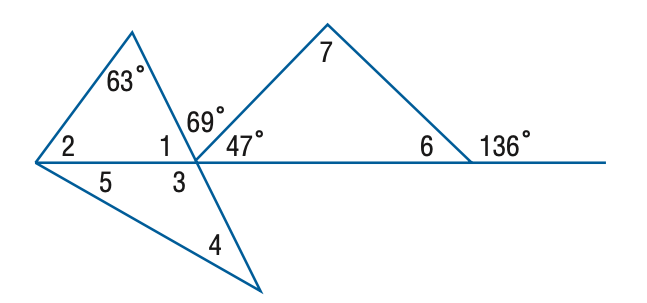Answer the mathemtical geometry problem and directly provide the correct option letter.
Question: Find the measure of \angle 4 if m \angle 4 = m \angle 5.
Choices: A: 32 B: 44 C: 47 D: 53 A 